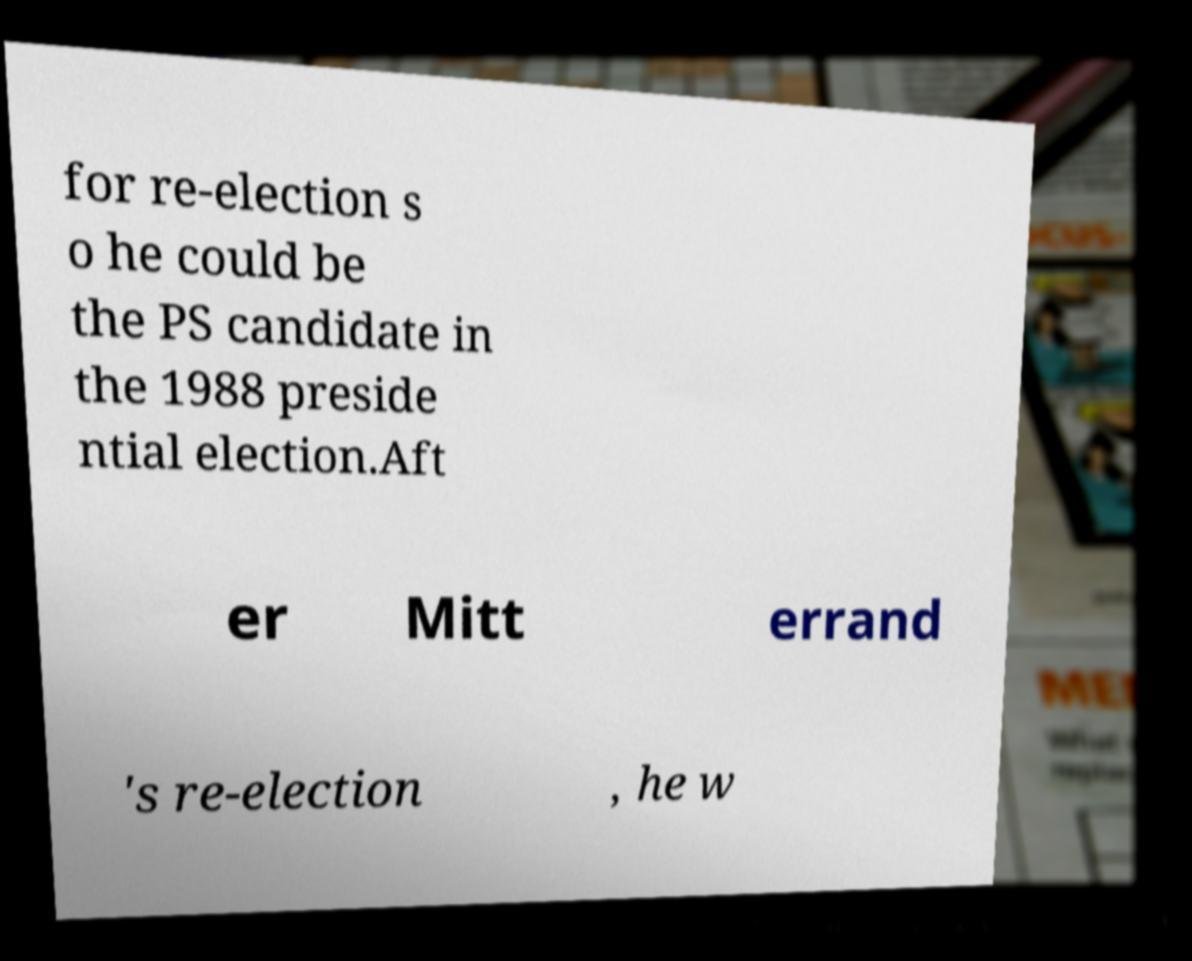Please identify and transcribe the text found in this image. for re-election s o he could be the PS candidate in the 1988 preside ntial election.Aft er Mitt errand 's re-election , he w 